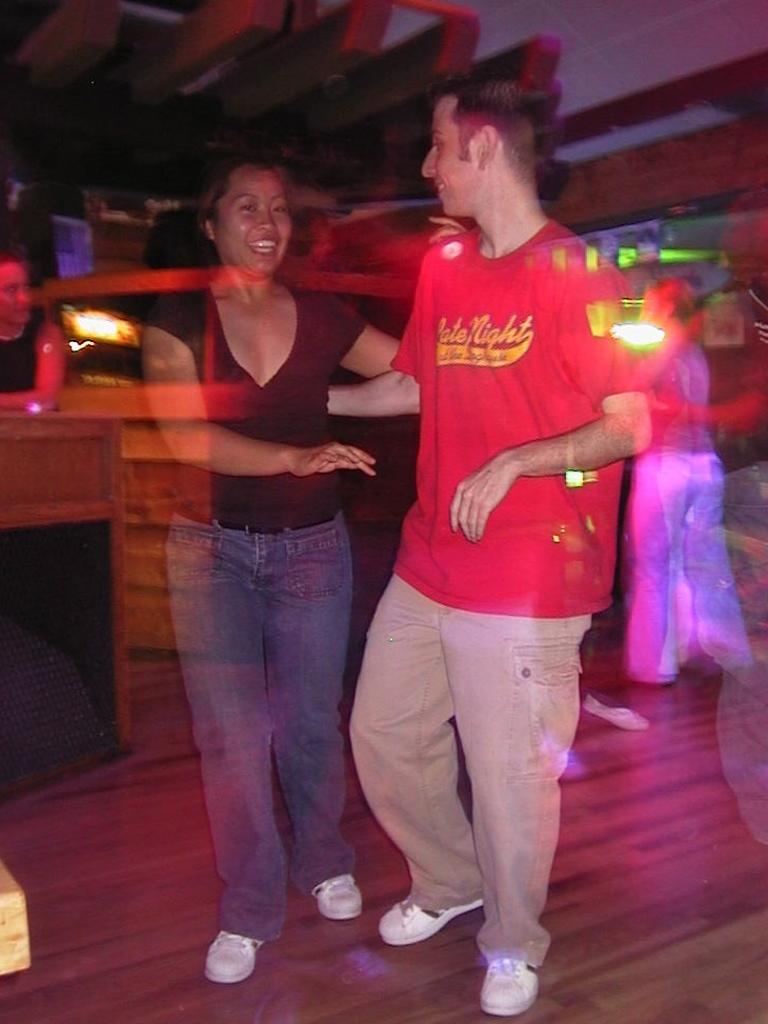Who or what is present in the image? There are people in the image. What is the surface beneath the people? There is a floor in the image. What piece of furniture can be seen in the image? There is a table in the image. What provides illumination in the image? There are lights in the image. Is there a body of water visible in the image? No, there is no body of water present in the image. 